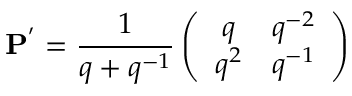Convert formula to latex. <formula><loc_0><loc_0><loc_500><loc_500>{ P } ^ { ^ { \prime } } = \frac { 1 } { q + q ^ { - 1 } } \left ( \begin{array} { c c } { q } & { { q ^ { - 2 } } } \\ { { q ^ { 2 } } } & { { q ^ { - 1 } } } \end{array} \right )</formula> 